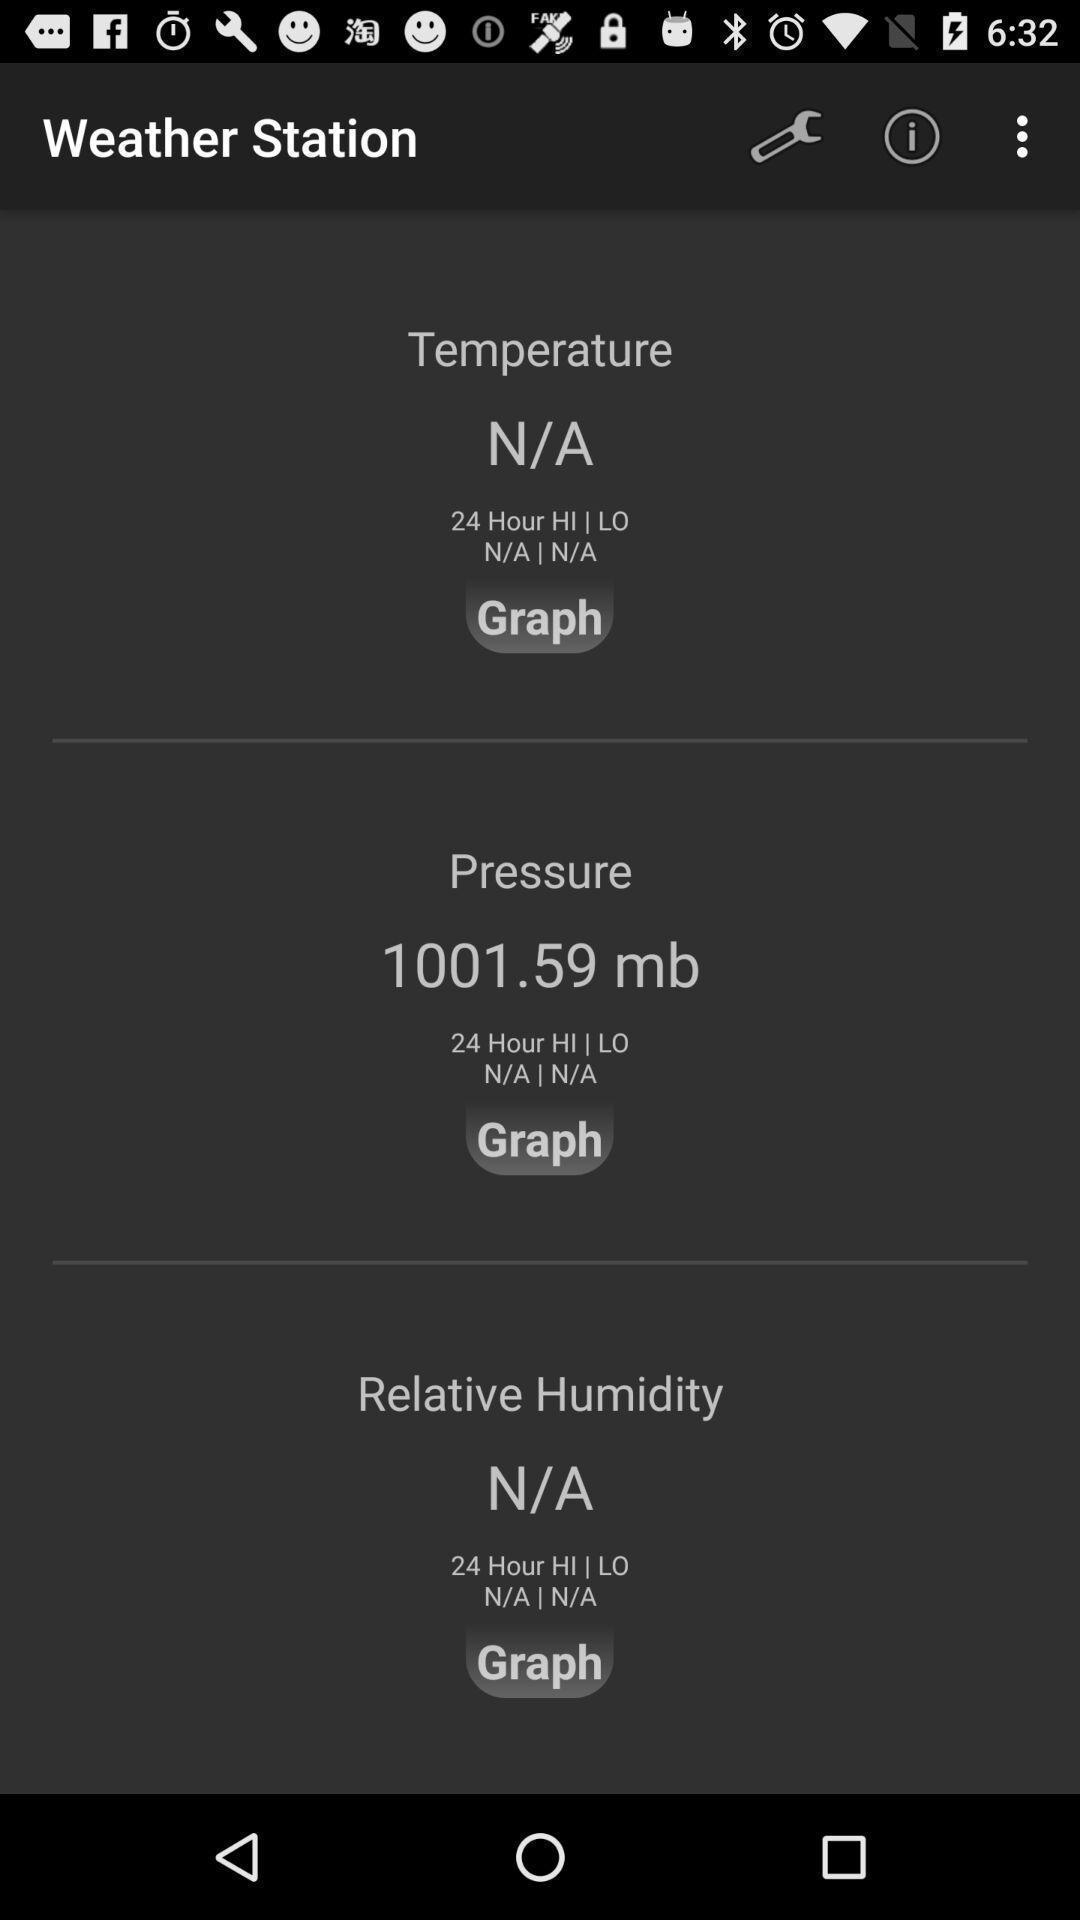What is the overall content of this screenshot? Page showing the weather stations. 